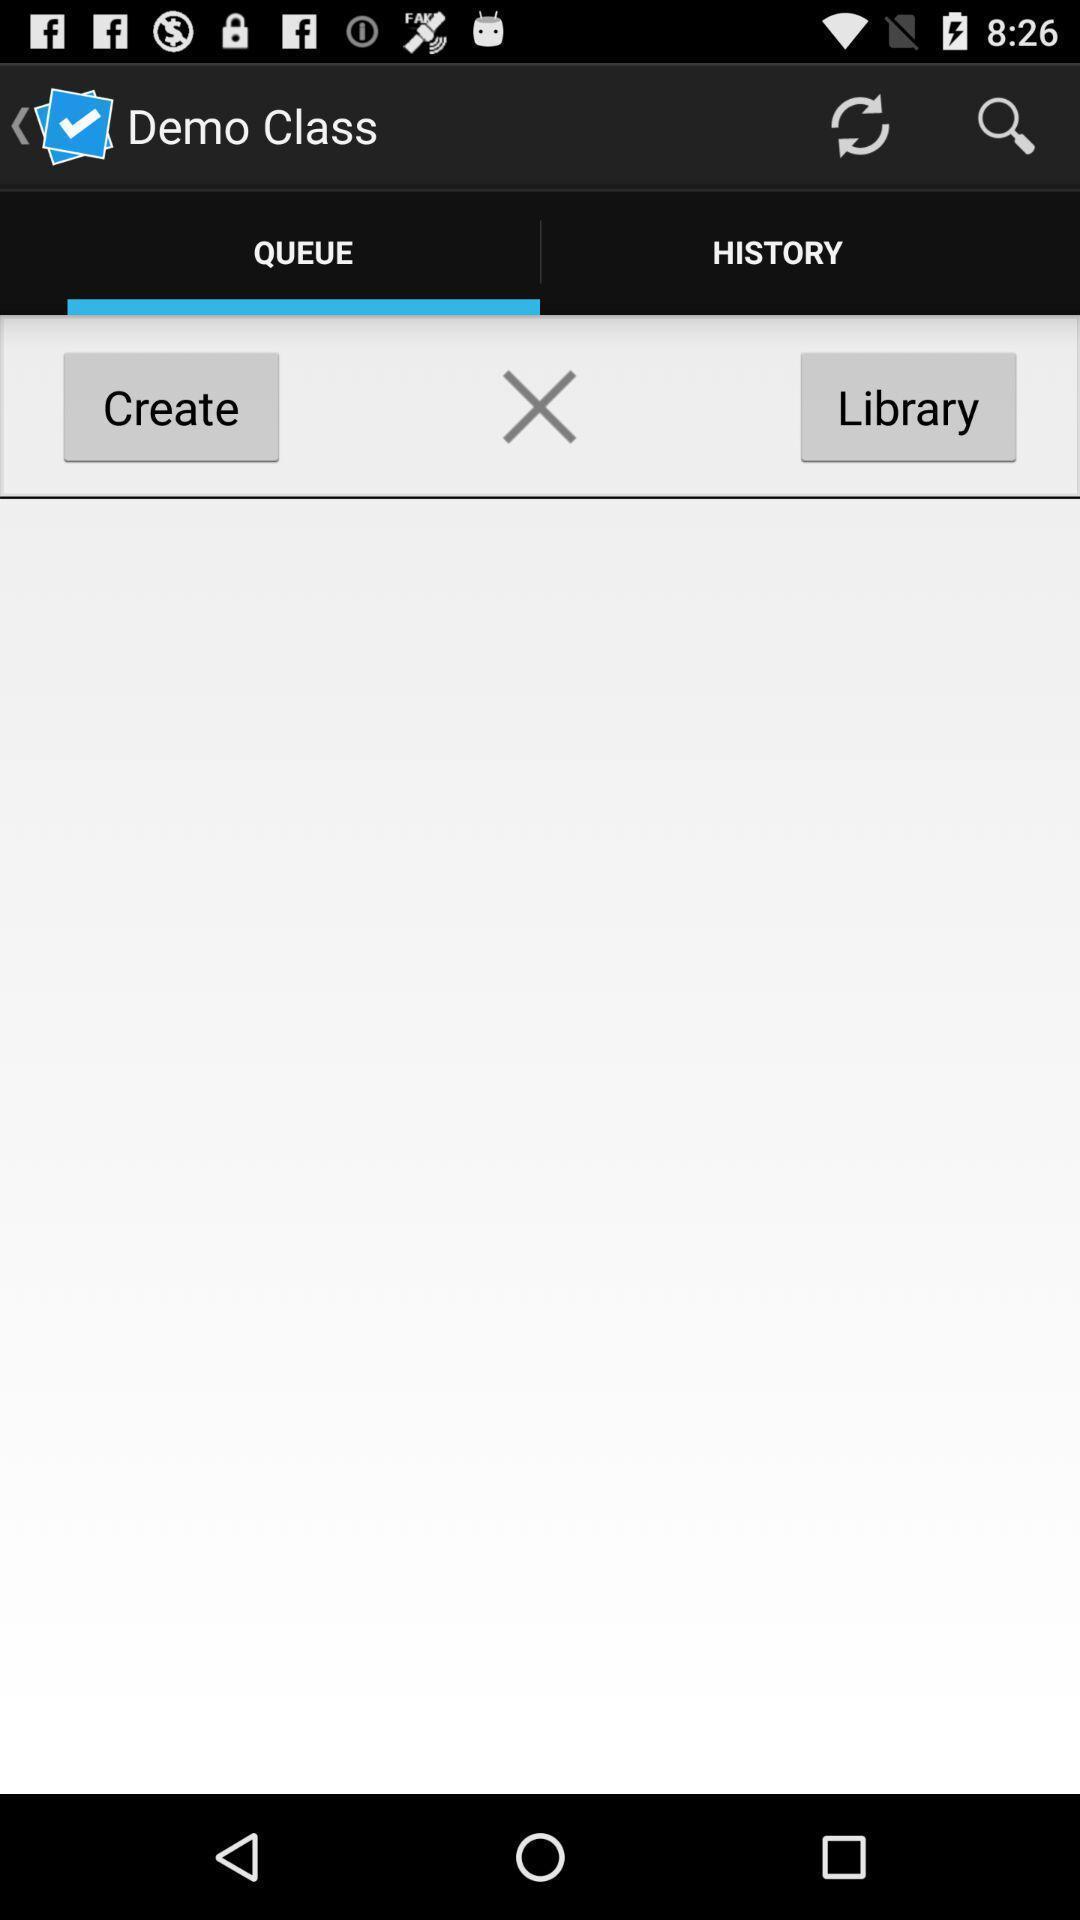Provide a textual representation of this image. Screen shows demo class. 